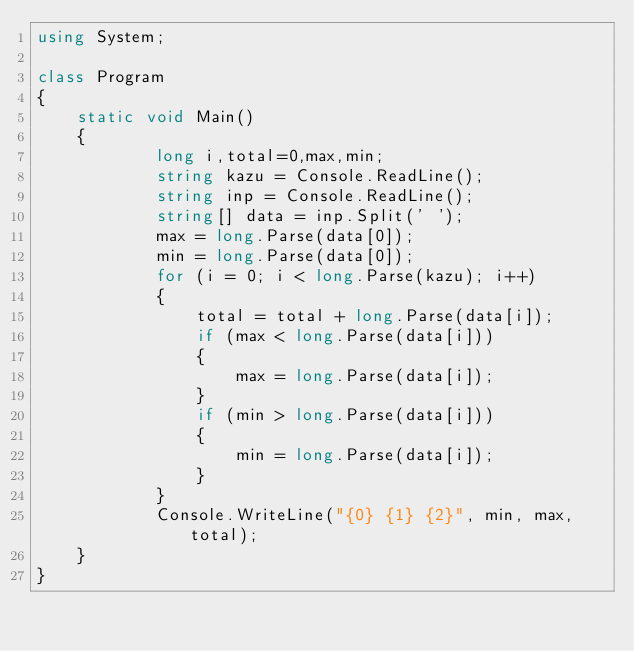<code> <loc_0><loc_0><loc_500><loc_500><_C#_>using System;

class Program
{
    static void Main()
    {
            long i,total=0,max,min;
            string kazu = Console.ReadLine();
            string inp = Console.ReadLine();
            string[] data = inp.Split(' ');
            max = long.Parse(data[0]);
            min = long.Parse(data[0]);
            for (i = 0; i < long.Parse(kazu); i++)
            {
                total = total + long.Parse(data[i]);
                if (max < long.Parse(data[i]))
                {
                    max = long.Parse(data[i]);
                }
                if (min > long.Parse(data[i]))
                {
                    min = long.Parse(data[i]);
                }
            }
            Console.WriteLine("{0} {1} {2}", min, max, total);
    }
}
</code> 